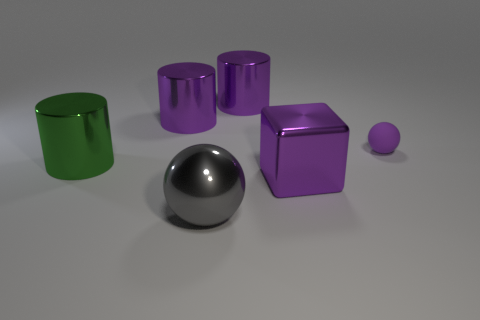Add 1 purple matte things. How many objects exist? 7 Subtract all balls. How many objects are left? 4 Add 4 large purple blocks. How many large purple blocks exist? 5 Subtract 0 brown blocks. How many objects are left? 6 Subtract all metallic cylinders. Subtract all large metallic blocks. How many objects are left? 2 Add 5 cylinders. How many cylinders are left? 8 